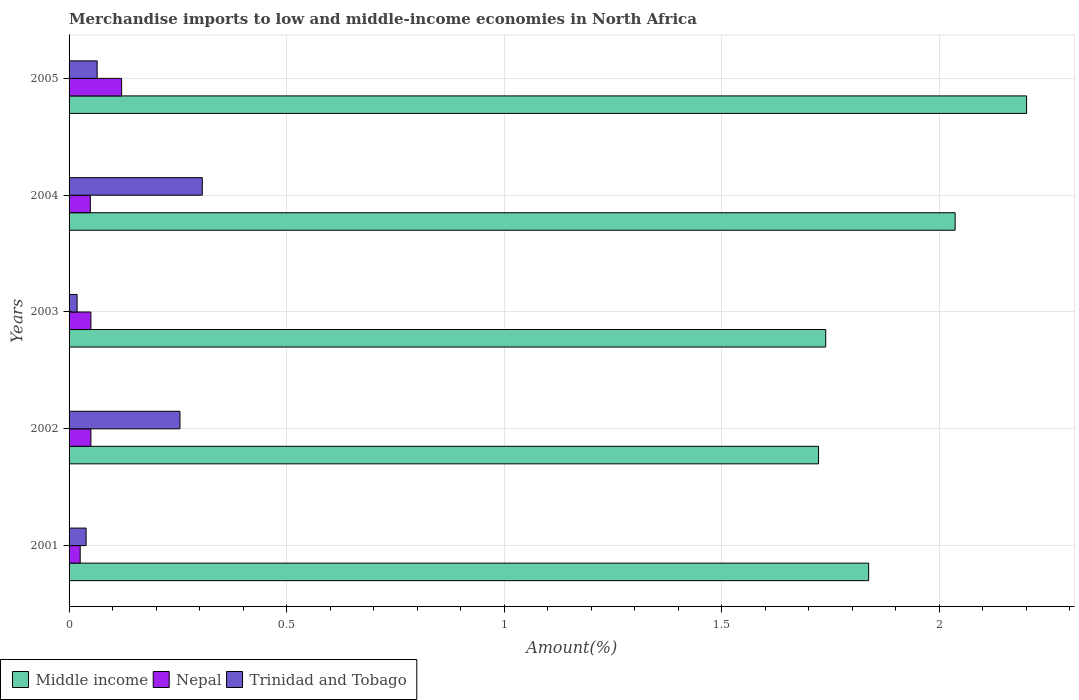Are the number of bars per tick equal to the number of legend labels?
Give a very brief answer. Yes. How many bars are there on the 5th tick from the top?
Make the answer very short. 3. How many bars are there on the 3rd tick from the bottom?
Offer a terse response. 3. What is the percentage of amount earned from merchandise imports in Middle income in 2002?
Keep it short and to the point. 1.72. Across all years, what is the maximum percentage of amount earned from merchandise imports in Nepal?
Make the answer very short. 0.12. Across all years, what is the minimum percentage of amount earned from merchandise imports in Middle income?
Give a very brief answer. 1.72. In which year was the percentage of amount earned from merchandise imports in Middle income minimum?
Your response must be concise. 2002. What is the total percentage of amount earned from merchandise imports in Nepal in the graph?
Provide a succinct answer. 0.3. What is the difference between the percentage of amount earned from merchandise imports in Middle income in 2004 and that in 2005?
Give a very brief answer. -0.16. What is the difference between the percentage of amount earned from merchandise imports in Nepal in 2003 and the percentage of amount earned from merchandise imports in Middle income in 2002?
Your response must be concise. -1.67. What is the average percentage of amount earned from merchandise imports in Nepal per year?
Give a very brief answer. 0.06. In the year 2005, what is the difference between the percentage of amount earned from merchandise imports in Trinidad and Tobago and percentage of amount earned from merchandise imports in Middle income?
Provide a succinct answer. -2.14. What is the ratio of the percentage of amount earned from merchandise imports in Nepal in 2001 to that in 2003?
Your response must be concise. 0.51. What is the difference between the highest and the second highest percentage of amount earned from merchandise imports in Nepal?
Offer a terse response. 0.07. What is the difference between the highest and the lowest percentage of amount earned from merchandise imports in Nepal?
Make the answer very short. 0.1. Is the sum of the percentage of amount earned from merchandise imports in Middle income in 2001 and 2002 greater than the maximum percentage of amount earned from merchandise imports in Trinidad and Tobago across all years?
Your response must be concise. Yes. What does the 3rd bar from the top in 2004 represents?
Offer a terse response. Middle income. What does the 3rd bar from the bottom in 2002 represents?
Your answer should be compact. Trinidad and Tobago. How many years are there in the graph?
Provide a short and direct response. 5. What is the difference between two consecutive major ticks on the X-axis?
Your answer should be compact. 0.5. Does the graph contain grids?
Offer a very short reply. Yes. Where does the legend appear in the graph?
Give a very brief answer. Bottom left. How many legend labels are there?
Your response must be concise. 3. How are the legend labels stacked?
Offer a terse response. Horizontal. What is the title of the graph?
Keep it short and to the point. Merchandise imports to low and middle-income economies in North Africa. Does "Cuba" appear as one of the legend labels in the graph?
Keep it short and to the point. No. What is the label or title of the X-axis?
Provide a short and direct response. Amount(%). What is the Amount(%) of Middle income in 2001?
Your response must be concise. 1.84. What is the Amount(%) of Nepal in 2001?
Keep it short and to the point. 0.03. What is the Amount(%) in Trinidad and Tobago in 2001?
Your response must be concise. 0.04. What is the Amount(%) of Middle income in 2002?
Offer a very short reply. 1.72. What is the Amount(%) in Nepal in 2002?
Provide a succinct answer. 0.05. What is the Amount(%) in Trinidad and Tobago in 2002?
Give a very brief answer. 0.25. What is the Amount(%) in Middle income in 2003?
Your answer should be very brief. 1.74. What is the Amount(%) of Nepal in 2003?
Ensure brevity in your answer.  0.05. What is the Amount(%) in Trinidad and Tobago in 2003?
Ensure brevity in your answer.  0.02. What is the Amount(%) of Middle income in 2004?
Give a very brief answer. 2.04. What is the Amount(%) in Nepal in 2004?
Keep it short and to the point. 0.05. What is the Amount(%) in Trinidad and Tobago in 2004?
Offer a terse response. 0.31. What is the Amount(%) in Middle income in 2005?
Your answer should be compact. 2.2. What is the Amount(%) in Nepal in 2005?
Make the answer very short. 0.12. What is the Amount(%) of Trinidad and Tobago in 2005?
Offer a very short reply. 0.06. Across all years, what is the maximum Amount(%) in Middle income?
Make the answer very short. 2.2. Across all years, what is the maximum Amount(%) in Nepal?
Make the answer very short. 0.12. Across all years, what is the maximum Amount(%) in Trinidad and Tobago?
Your response must be concise. 0.31. Across all years, what is the minimum Amount(%) in Middle income?
Your answer should be very brief. 1.72. Across all years, what is the minimum Amount(%) of Nepal?
Make the answer very short. 0.03. Across all years, what is the minimum Amount(%) in Trinidad and Tobago?
Keep it short and to the point. 0.02. What is the total Amount(%) of Middle income in the graph?
Ensure brevity in your answer.  9.54. What is the total Amount(%) of Nepal in the graph?
Offer a terse response. 0.3. What is the total Amount(%) in Trinidad and Tobago in the graph?
Offer a very short reply. 0.68. What is the difference between the Amount(%) of Middle income in 2001 and that in 2002?
Your answer should be very brief. 0.12. What is the difference between the Amount(%) in Nepal in 2001 and that in 2002?
Provide a succinct answer. -0.02. What is the difference between the Amount(%) of Trinidad and Tobago in 2001 and that in 2002?
Provide a succinct answer. -0.22. What is the difference between the Amount(%) of Middle income in 2001 and that in 2003?
Provide a succinct answer. 0.1. What is the difference between the Amount(%) of Nepal in 2001 and that in 2003?
Your response must be concise. -0.02. What is the difference between the Amount(%) of Trinidad and Tobago in 2001 and that in 2003?
Keep it short and to the point. 0.02. What is the difference between the Amount(%) in Middle income in 2001 and that in 2004?
Keep it short and to the point. -0.2. What is the difference between the Amount(%) of Nepal in 2001 and that in 2004?
Your answer should be very brief. -0.02. What is the difference between the Amount(%) in Trinidad and Tobago in 2001 and that in 2004?
Make the answer very short. -0.27. What is the difference between the Amount(%) of Middle income in 2001 and that in 2005?
Ensure brevity in your answer.  -0.36. What is the difference between the Amount(%) in Nepal in 2001 and that in 2005?
Your answer should be very brief. -0.1. What is the difference between the Amount(%) of Trinidad and Tobago in 2001 and that in 2005?
Offer a very short reply. -0.03. What is the difference between the Amount(%) of Middle income in 2002 and that in 2003?
Offer a very short reply. -0.02. What is the difference between the Amount(%) in Nepal in 2002 and that in 2003?
Keep it short and to the point. -0. What is the difference between the Amount(%) in Trinidad and Tobago in 2002 and that in 2003?
Your answer should be very brief. 0.24. What is the difference between the Amount(%) in Middle income in 2002 and that in 2004?
Make the answer very short. -0.31. What is the difference between the Amount(%) of Nepal in 2002 and that in 2004?
Your answer should be very brief. 0. What is the difference between the Amount(%) in Trinidad and Tobago in 2002 and that in 2004?
Provide a short and direct response. -0.05. What is the difference between the Amount(%) of Middle income in 2002 and that in 2005?
Keep it short and to the point. -0.48. What is the difference between the Amount(%) of Nepal in 2002 and that in 2005?
Offer a terse response. -0.07. What is the difference between the Amount(%) of Trinidad and Tobago in 2002 and that in 2005?
Your answer should be very brief. 0.19. What is the difference between the Amount(%) in Middle income in 2003 and that in 2004?
Keep it short and to the point. -0.3. What is the difference between the Amount(%) of Nepal in 2003 and that in 2004?
Your response must be concise. 0. What is the difference between the Amount(%) in Trinidad and Tobago in 2003 and that in 2004?
Offer a terse response. -0.29. What is the difference between the Amount(%) in Middle income in 2003 and that in 2005?
Offer a very short reply. -0.46. What is the difference between the Amount(%) in Nepal in 2003 and that in 2005?
Keep it short and to the point. -0.07. What is the difference between the Amount(%) of Trinidad and Tobago in 2003 and that in 2005?
Your answer should be very brief. -0.05. What is the difference between the Amount(%) in Middle income in 2004 and that in 2005?
Your response must be concise. -0.16. What is the difference between the Amount(%) in Nepal in 2004 and that in 2005?
Keep it short and to the point. -0.07. What is the difference between the Amount(%) in Trinidad and Tobago in 2004 and that in 2005?
Make the answer very short. 0.24. What is the difference between the Amount(%) of Middle income in 2001 and the Amount(%) of Nepal in 2002?
Give a very brief answer. 1.79. What is the difference between the Amount(%) of Middle income in 2001 and the Amount(%) of Trinidad and Tobago in 2002?
Your answer should be very brief. 1.58. What is the difference between the Amount(%) in Nepal in 2001 and the Amount(%) in Trinidad and Tobago in 2002?
Your answer should be compact. -0.23. What is the difference between the Amount(%) in Middle income in 2001 and the Amount(%) in Nepal in 2003?
Provide a succinct answer. 1.79. What is the difference between the Amount(%) of Middle income in 2001 and the Amount(%) of Trinidad and Tobago in 2003?
Ensure brevity in your answer.  1.82. What is the difference between the Amount(%) of Nepal in 2001 and the Amount(%) of Trinidad and Tobago in 2003?
Give a very brief answer. 0.01. What is the difference between the Amount(%) in Middle income in 2001 and the Amount(%) in Nepal in 2004?
Ensure brevity in your answer.  1.79. What is the difference between the Amount(%) in Middle income in 2001 and the Amount(%) in Trinidad and Tobago in 2004?
Your answer should be very brief. 1.53. What is the difference between the Amount(%) of Nepal in 2001 and the Amount(%) of Trinidad and Tobago in 2004?
Ensure brevity in your answer.  -0.28. What is the difference between the Amount(%) in Middle income in 2001 and the Amount(%) in Nepal in 2005?
Your answer should be very brief. 1.72. What is the difference between the Amount(%) of Middle income in 2001 and the Amount(%) of Trinidad and Tobago in 2005?
Ensure brevity in your answer.  1.77. What is the difference between the Amount(%) in Nepal in 2001 and the Amount(%) in Trinidad and Tobago in 2005?
Provide a short and direct response. -0.04. What is the difference between the Amount(%) in Middle income in 2002 and the Amount(%) in Nepal in 2003?
Your response must be concise. 1.67. What is the difference between the Amount(%) in Middle income in 2002 and the Amount(%) in Trinidad and Tobago in 2003?
Give a very brief answer. 1.7. What is the difference between the Amount(%) in Nepal in 2002 and the Amount(%) in Trinidad and Tobago in 2003?
Provide a short and direct response. 0.03. What is the difference between the Amount(%) of Middle income in 2002 and the Amount(%) of Nepal in 2004?
Ensure brevity in your answer.  1.67. What is the difference between the Amount(%) of Middle income in 2002 and the Amount(%) of Trinidad and Tobago in 2004?
Ensure brevity in your answer.  1.42. What is the difference between the Amount(%) of Nepal in 2002 and the Amount(%) of Trinidad and Tobago in 2004?
Keep it short and to the point. -0.26. What is the difference between the Amount(%) of Middle income in 2002 and the Amount(%) of Nepal in 2005?
Provide a succinct answer. 1.6. What is the difference between the Amount(%) in Middle income in 2002 and the Amount(%) in Trinidad and Tobago in 2005?
Offer a very short reply. 1.66. What is the difference between the Amount(%) of Nepal in 2002 and the Amount(%) of Trinidad and Tobago in 2005?
Ensure brevity in your answer.  -0.01. What is the difference between the Amount(%) of Middle income in 2003 and the Amount(%) of Nepal in 2004?
Offer a terse response. 1.69. What is the difference between the Amount(%) of Middle income in 2003 and the Amount(%) of Trinidad and Tobago in 2004?
Give a very brief answer. 1.43. What is the difference between the Amount(%) of Nepal in 2003 and the Amount(%) of Trinidad and Tobago in 2004?
Offer a very short reply. -0.26. What is the difference between the Amount(%) in Middle income in 2003 and the Amount(%) in Nepal in 2005?
Offer a very short reply. 1.62. What is the difference between the Amount(%) of Middle income in 2003 and the Amount(%) of Trinidad and Tobago in 2005?
Ensure brevity in your answer.  1.67. What is the difference between the Amount(%) of Nepal in 2003 and the Amount(%) of Trinidad and Tobago in 2005?
Provide a short and direct response. -0.01. What is the difference between the Amount(%) in Middle income in 2004 and the Amount(%) in Nepal in 2005?
Offer a very short reply. 1.92. What is the difference between the Amount(%) of Middle income in 2004 and the Amount(%) of Trinidad and Tobago in 2005?
Your response must be concise. 1.97. What is the difference between the Amount(%) of Nepal in 2004 and the Amount(%) of Trinidad and Tobago in 2005?
Offer a terse response. -0.02. What is the average Amount(%) of Middle income per year?
Ensure brevity in your answer.  1.91. What is the average Amount(%) of Nepal per year?
Offer a terse response. 0.06. What is the average Amount(%) in Trinidad and Tobago per year?
Offer a terse response. 0.14. In the year 2001, what is the difference between the Amount(%) of Middle income and Amount(%) of Nepal?
Keep it short and to the point. 1.81. In the year 2001, what is the difference between the Amount(%) in Middle income and Amount(%) in Trinidad and Tobago?
Your response must be concise. 1.8. In the year 2001, what is the difference between the Amount(%) in Nepal and Amount(%) in Trinidad and Tobago?
Make the answer very short. -0.01. In the year 2002, what is the difference between the Amount(%) in Middle income and Amount(%) in Nepal?
Your answer should be very brief. 1.67. In the year 2002, what is the difference between the Amount(%) in Middle income and Amount(%) in Trinidad and Tobago?
Your answer should be very brief. 1.47. In the year 2002, what is the difference between the Amount(%) of Nepal and Amount(%) of Trinidad and Tobago?
Your response must be concise. -0.2. In the year 2003, what is the difference between the Amount(%) in Middle income and Amount(%) in Nepal?
Give a very brief answer. 1.69. In the year 2003, what is the difference between the Amount(%) of Middle income and Amount(%) of Trinidad and Tobago?
Provide a short and direct response. 1.72. In the year 2003, what is the difference between the Amount(%) of Nepal and Amount(%) of Trinidad and Tobago?
Provide a succinct answer. 0.03. In the year 2004, what is the difference between the Amount(%) of Middle income and Amount(%) of Nepal?
Your answer should be very brief. 1.99. In the year 2004, what is the difference between the Amount(%) in Middle income and Amount(%) in Trinidad and Tobago?
Give a very brief answer. 1.73. In the year 2004, what is the difference between the Amount(%) in Nepal and Amount(%) in Trinidad and Tobago?
Your answer should be very brief. -0.26. In the year 2005, what is the difference between the Amount(%) in Middle income and Amount(%) in Nepal?
Offer a very short reply. 2.08. In the year 2005, what is the difference between the Amount(%) of Middle income and Amount(%) of Trinidad and Tobago?
Provide a short and direct response. 2.14. In the year 2005, what is the difference between the Amount(%) in Nepal and Amount(%) in Trinidad and Tobago?
Ensure brevity in your answer.  0.06. What is the ratio of the Amount(%) of Middle income in 2001 to that in 2002?
Provide a short and direct response. 1.07. What is the ratio of the Amount(%) of Nepal in 2001 to that in 2002?
Offer a very short reply. 0.51. What is the ratio of the Amount(%) of Trinidad and Tobago in 2001 to that in 2002?
Your answer should be very brief. 0.15. What is the ratio of the Amount(%) of Middle income in 2001 to that in 2003?
Make the answer very short. 1.06. What is the ratio of the Amount(%) in Nepal in 2001 to that in 2003?
Your answer should be compact. 0.51. What is the ratio of the Amount(%) of Trinidad and Tobago in 2001 to that in 2003?
Ensure brevity in your answer.  2.12. What is the ratio of the Amount(%) in Middle income in 2001 to that in 2004?
Keep it short and to the point. 0.9. What is the ratio of the Amount(%) in Nepal in 2001 to that in 2004?
Provide a short and direct response. 0.52. What is the ratio of the Amount(%) of Trinidad and Tobago in 2001 to that in 2004?
Offer a very short reply. 0.13. What is the ratio of the Amount(%) in Middle income in 2001 to that in 2005?
Ensure brevity in your answer.  0.83. What is the ratio of the Amount(%) in Nepal in 2001 to that in 2005?
Your answer should be compact. 0.21. What is the ratio of the Amount(%) in Trinidad and Tobago in 2001 to that in 2005?
Provide a succinct answer. 0.61. What is the ratio of the Amount(%) in Middle income in 2002 to that in 2003?
Provide a succinct answer. 0.99. What is the ratio of the Amount(%) of Trinidad and Tobago in 2002 to that in 2003?
Make the answer very short. 13.82. What is the ratio of the Amount(%) of Middle income in 2002 to that in 2004?
Keep it short and to the point. 0.85. What is the ratio of the Amount(%) of Nepal in 2002 to that in 2004?
Give a very brief answer. 1.03. What is the ratio of the Amount(%) of Trinidad and Tobago in 2002 to that in 2004?
Your response must be concise. 0.83. What is the ratio of the Amount(%) in Middle income in 2002 to that in 2005?
Keep it short and to the point. 0.78. What is the ratio of the Amount(%) of Nepal in 2002 to that in 2005?
Your response must be concise. 0.42. What is the ratio of the Amount(%) of Trinidad and Tobago in 2002 to that in 2005?
Ensure brevity in your answer.  3.95. What is the ratio of the Amount(%) of Middle income in 2003 to that in 2004?
Your response must be concise. 0.85. What is the ratio of the Amount(%) of Nepal in 2003 to that in 2004?
Ensure brevity in your answer.  1.03. What is the ratio of the Amount(%) of Trinidad and Tobago in 2003 to that in 2004?
Offer a very short reply. 0.06. What is the ratio of the Amount(%) in Middle income in 2003 to that in 2005?
Keep it short and to the point. 0.79. What is the ratio of the Amount(%) in Nepal in 2003 to that in 2005?
Ensure brevity in your answer.  0.42. What is the ratio of the Amount(%) of Trinidad and Tobago in 2003 to that in 2005?
Make the answer very short. 0.29. What is the ratio of the Amount(%) of Middle income in 2004 to that in 2005?
Your answer should be compact. 0.93. What is the ratio of the Amount(%) of Nepal in 2004 to that in 2005?
Your response must be concise. 0.4. What is the ratio of the Amount(%) of Trinidad and Tobago in 2004 to that in 2005?
Your answer should be compact. 4.75. What is the difference between the highest and the second highest Amount(%) in Middle income?
Offer a terse response. 0.16. What is the difference between the highest and the second highest Amount(%) of Nepal?
Give a very brief answer. 0.07. What is the difference between the highest and the second highest Amount(%) in Trinidad and Tobago?
Provide a succinct answer. 0.05. What is the difference between the highest and the lowest Amount(%) of Middle income?
Your answer should be compact. 0.48. What is the difference between the highest and the lowest Amount(%) of Nepal?
Make the answer very short. 0.1. What is the difference between the highest and the lowest Amount(%) of Trinidad and Tobago?
Offer a very short reply. 0.29. 